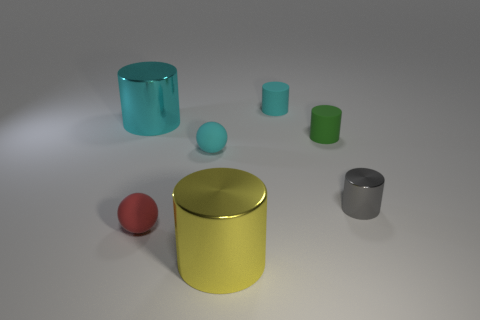There is a rubber cylinder in front of the large cyan cylinder; does it have the same size as the ball on the right side of the red rubber object?
Give a very brief answer. Yes. There is a green object that is the same shape as the large cyan thing; what is its material?
Offer a terse response. Rubber. How many large objects are gray shiny blocks or green rubber things?
Offer a terse response. 0. What is the material of the large cyan cylinder?
Give a very brief answer. Metal. There is a cylinder that is to the left of the tiny cyan cylinder and behind the gray cylinder; what is its material?
Give a very brief answer. Metal. There is a green cylinder that is the same size as the gray object; what is it made of?
Offer a very short reply. Rubber. Is there a gray object made of the same material as the tiny cyan ball?
Your answer should be very brief. No. What number of tiny green things are there?
Your answer should be compact. 1. Are the red sphere and the cyan cylinder that is to the left of the tiny cyan matte cylinder made of the same material?
Your answer should be compact. No. How many big shiny objects have the same color as the small metallic cylinder?
Your answer should be very brief. 0. 